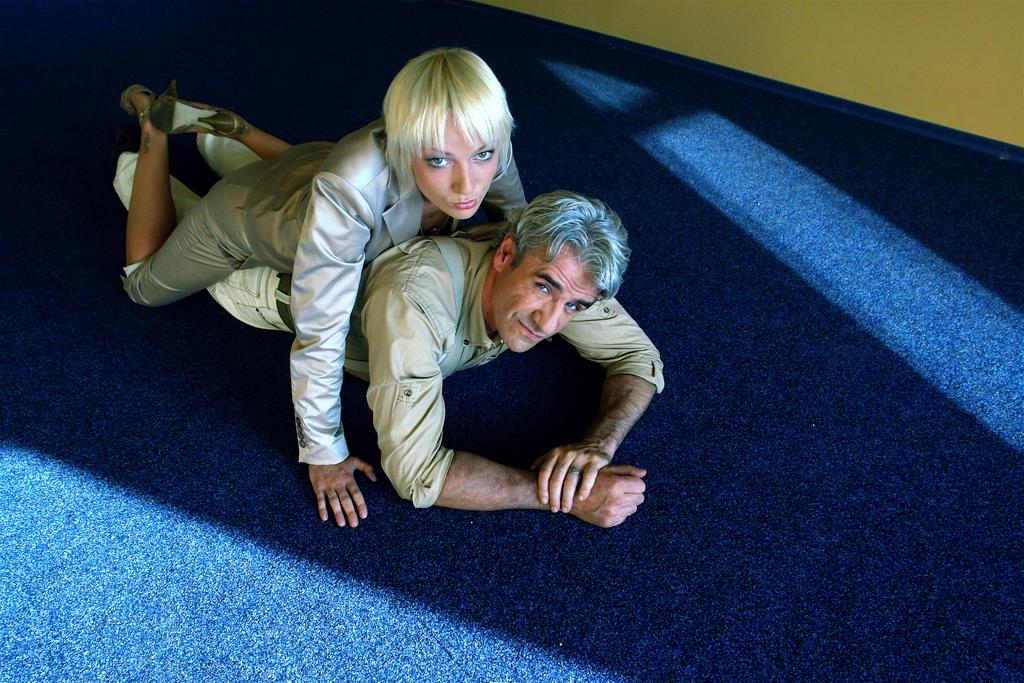What is the man doing in the image? The man is lying on a blue surface in the image. Is there anyone else in the image with the man? Yes, there is a woman lying on the man in the image. What can be seen in the top right corner of the image? There is a wall in the top right corner of the image. What type of cream is being used to transport the man in the image? There is no cream or transportation involved in the image; it simply shows a man and a woman lying on a blue surface. 